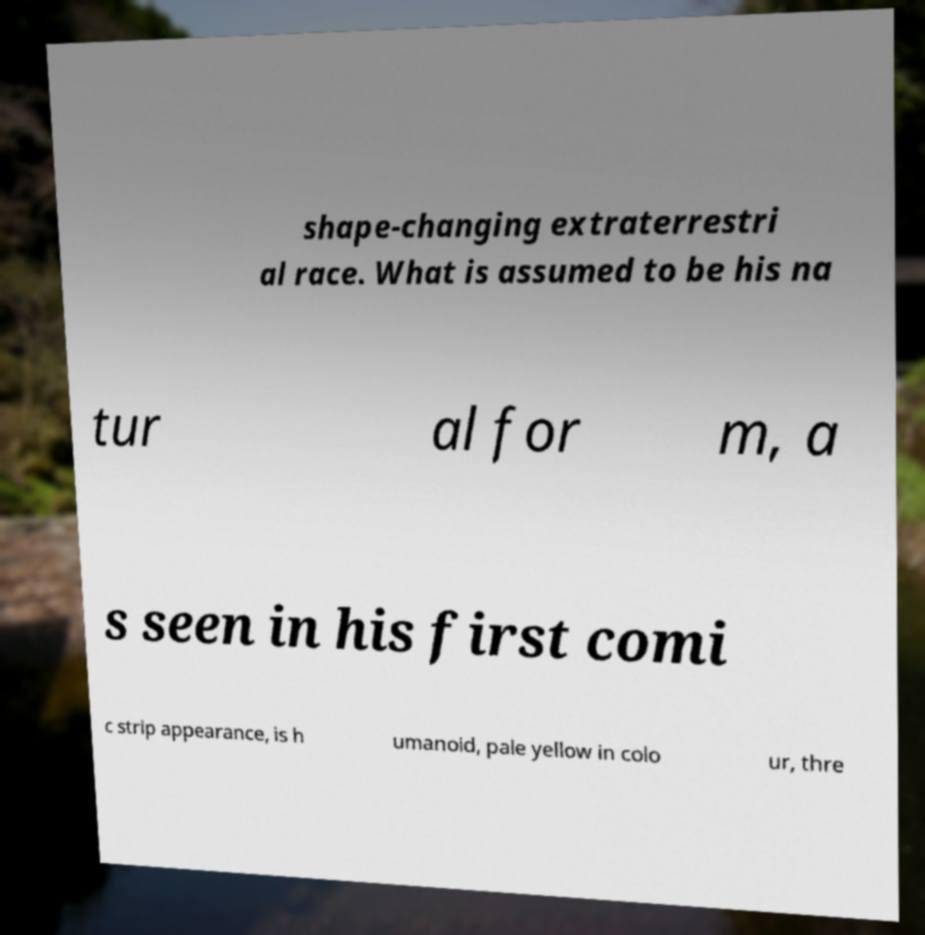Can you read and provide the text displayed in the image?This photo seems to have some interesting text. Can you extract and type it out for me? shape-changing extraterrestri al race. What is assumed to be his na tur al for m, a s seen in his first comi c strip appearance, is h umanoid, pale yellow in colo ur, thre 